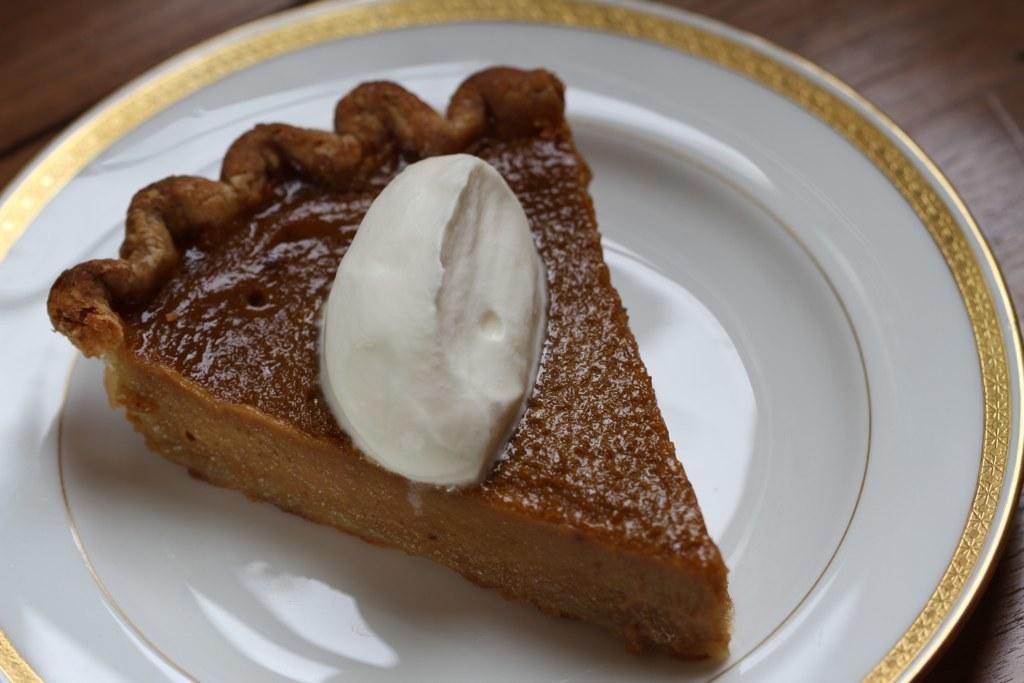How would you summarize this image in a sentence or two? In this image, there is a plate contains a cake. 